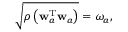Convert formula to latex. <formula><loc_0><loc_0><loc_500><loc_500>\begin{array} { r } { \sqrt { \rho \left ( w _ { a } ^ { T } w _ { a } \right ) } = \omega _ { a } , } \end{array}</formula> 